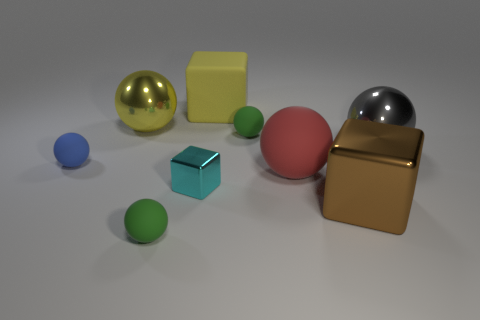Are there more big yellow cubes than big green metal cylinders?
Offer a terse response. Yes. There is a shiny ball behind the metal ball that is right of the big matte object that is in front of the big yellow matte thing; how big is it?
Your answer should be very brief. Large. Do the gray metal thing and the cyan metallic cube in front of the gray sphere have the same size?
Keep it short and to the point. No. Are there fewer small metal objects that are right of the large gray shiny sphere than big metal spheres?
Make the answer very short. Yes. What number of balls have the same color as the small metal thing?
Your response must be concise. 0. Are there fewer cyan things than green rubber balls?
Keep it short and to the point. Yes. Is the material of the large yellow sphere the same as the blue ball?
Your answer should be very brief. No. What number of other things are the same size as the red object?
Your answer should be compact. 4. What is the color of the metal cube that is on the left side of the green matte ball that is behind the red rubber thing?
Offer a very short reply. Cyan. What number of other things are the same shape as the large yellow matte object?
Keep it short and to the point. 2. 